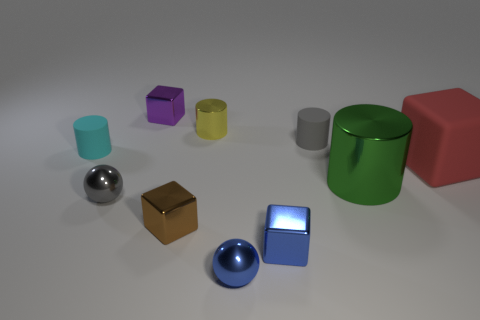What can you tell me about the lighting in the scene? The lighting in the scene is soft and diffuse, likely from an overhead source, casting subtle shadows that help accentuate the dimensions and textures of the objects. Does the lighting create any particular atmosphere? The softness and uniformity of the lighting give the scene a calm and clinical atmosphere, highlighting the simplicity and the colors of the objects. 